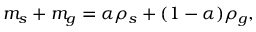<formula> <loc_0><loc_0><loc_500><loc_500>m _ { s } + m _ { g } = \alpha \rho _ { s } + ( 1 - \alpha ) \rho _ { g } ,</formula> 